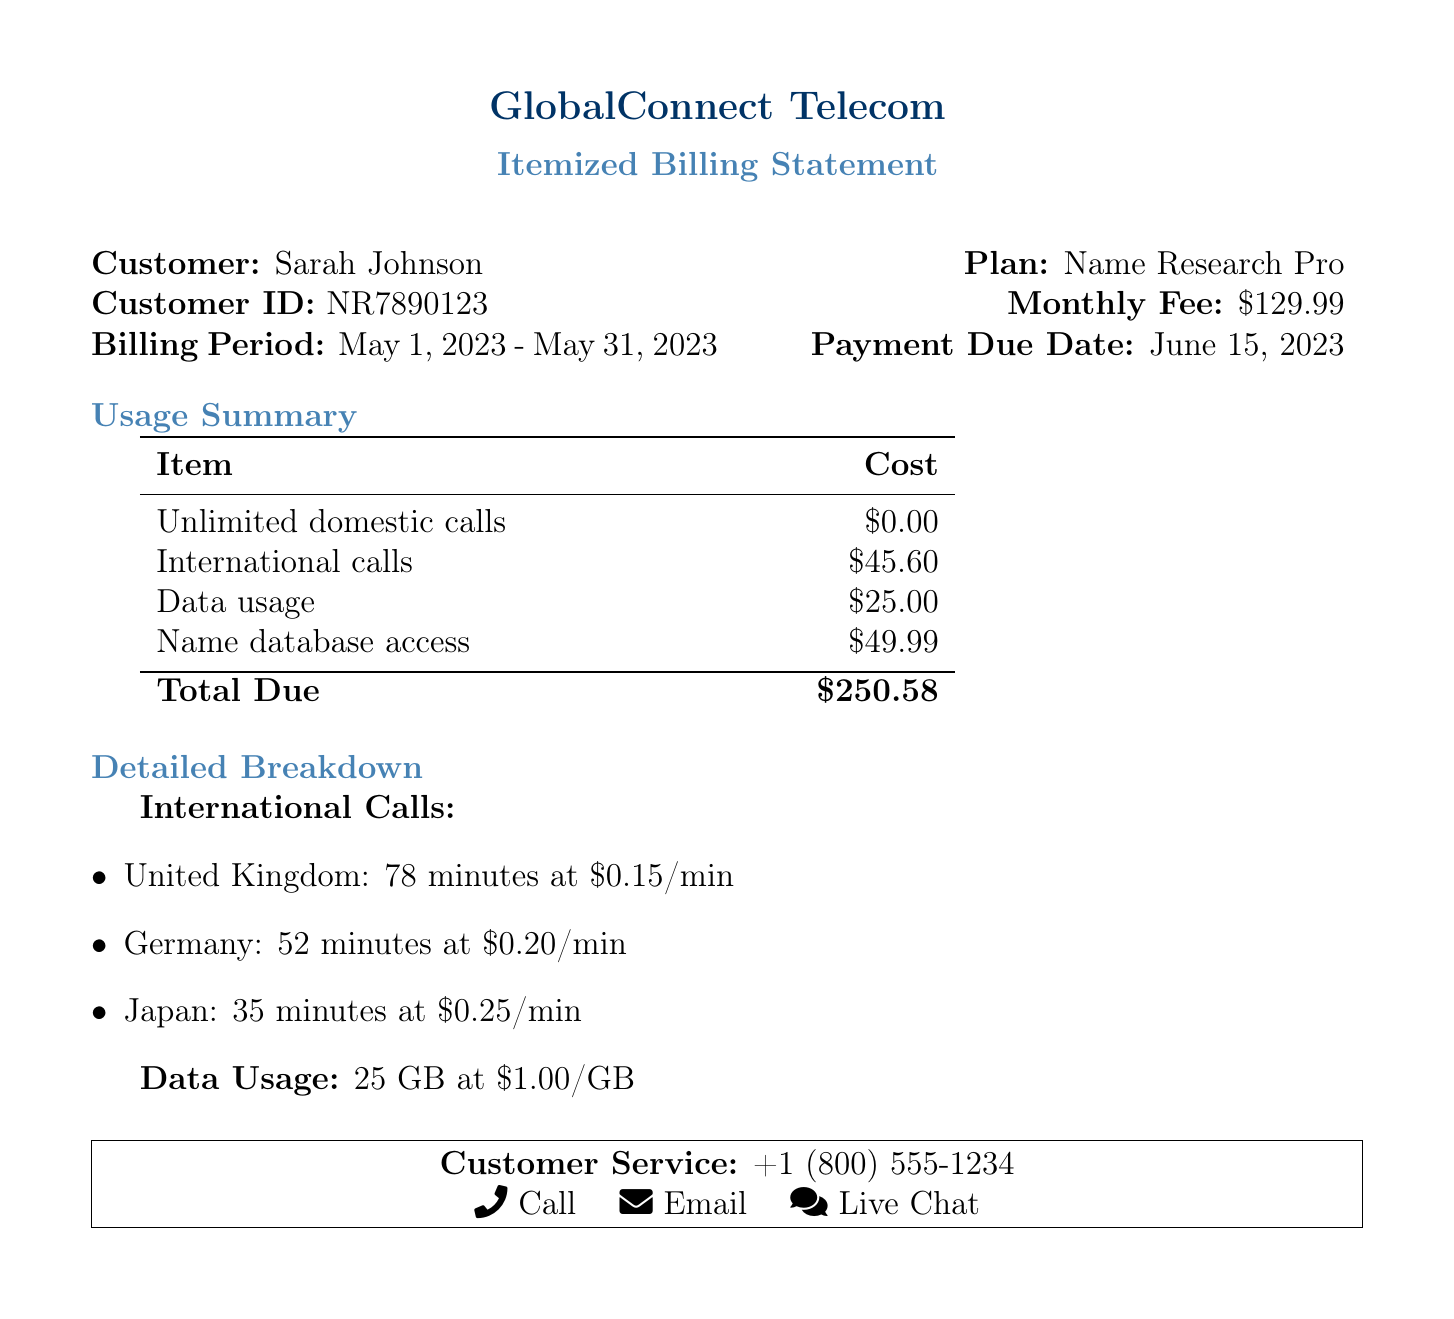what is the customer ID? The customer ID is specified in the document under the customer information section as NR7890123.
Answer: NR7890123 what is the monthly fee? The monthly fee is listed in the plan information section, which states that it is $129.99.
Answer: $129.99 what is the total amount due? The total amount due is found at the bottom of the usage summary, which is stated as $250.58.
Answer: $250.58 how many minutes were used for calls to Germany? The document contains a detailed breakdown of international calls that indicates 52 minutes were used for calls to Germany.
Answer: 52 minutes what is the cost for data usage? The data usage cost is detailed in the usage summary, listed as $25.00.
Answer: $25.00 what is the cost per minute for calls to Japan? The breakdown of international calls provides the rate for calls to Japan, which is $0.25 per minute.
Answer: $0.25/min how many gigabytes of data were used? The document specifies that 25 GB of data was used, as noted in the data usage section.
Answer: 25 GB which country incurred the highest cost for international calls? The reasoning is found in the detailed breakdown, where costs for each country are compared, with the United Kingdom incurring the highest total.
Answer: United Kingdom what is the payment due date? The payment due date is specified in the plan information section, which indicates it as June 15, 2023.
Answer: June 15, 2023 